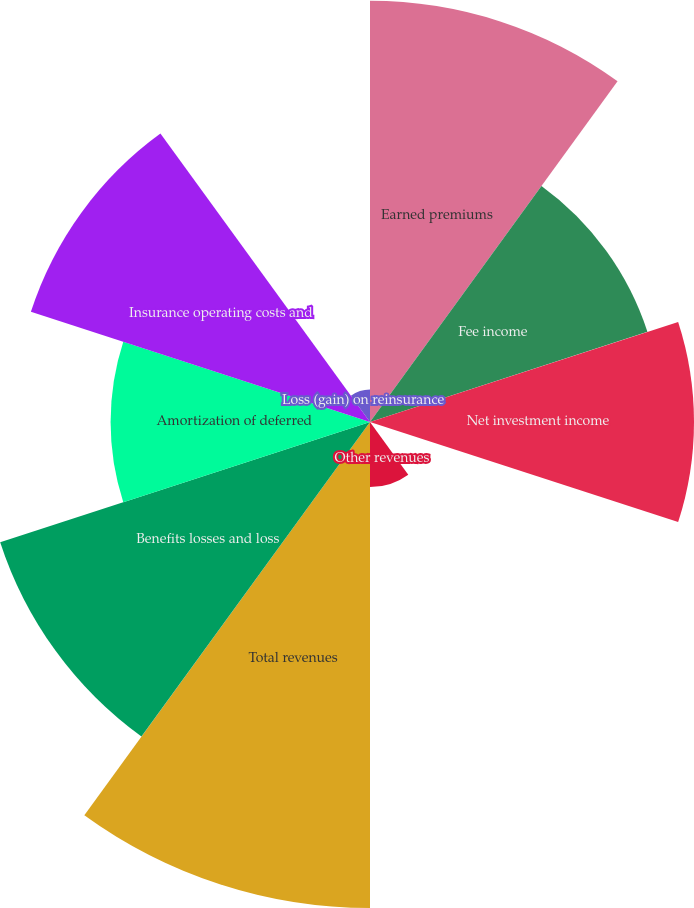Convert chart to OTSL. <chart><loc_0><loc_0><loc_500><loc_500><pie_chart><fcel>Earned premiums<fcel>Fee income<fcel>Net investment income<fcel>Net realized capital gains<fcel>Other revenues<fcel>Total revenues<fcel>Benefits losses and loss<fcel>Amortization of deferred<fcel>Insurance operating costs and<fcel>Loss (gain) on reinsurance<nl><fcel>16.04%<fcel>11.11%<fcel>12.34%<fcel>0.01%<fcel>2.48%<fcel>18.51%<fcel>14.81%<fcel>9.88%<fcel>13.58%<fcel>1.24%<nl></chart> 